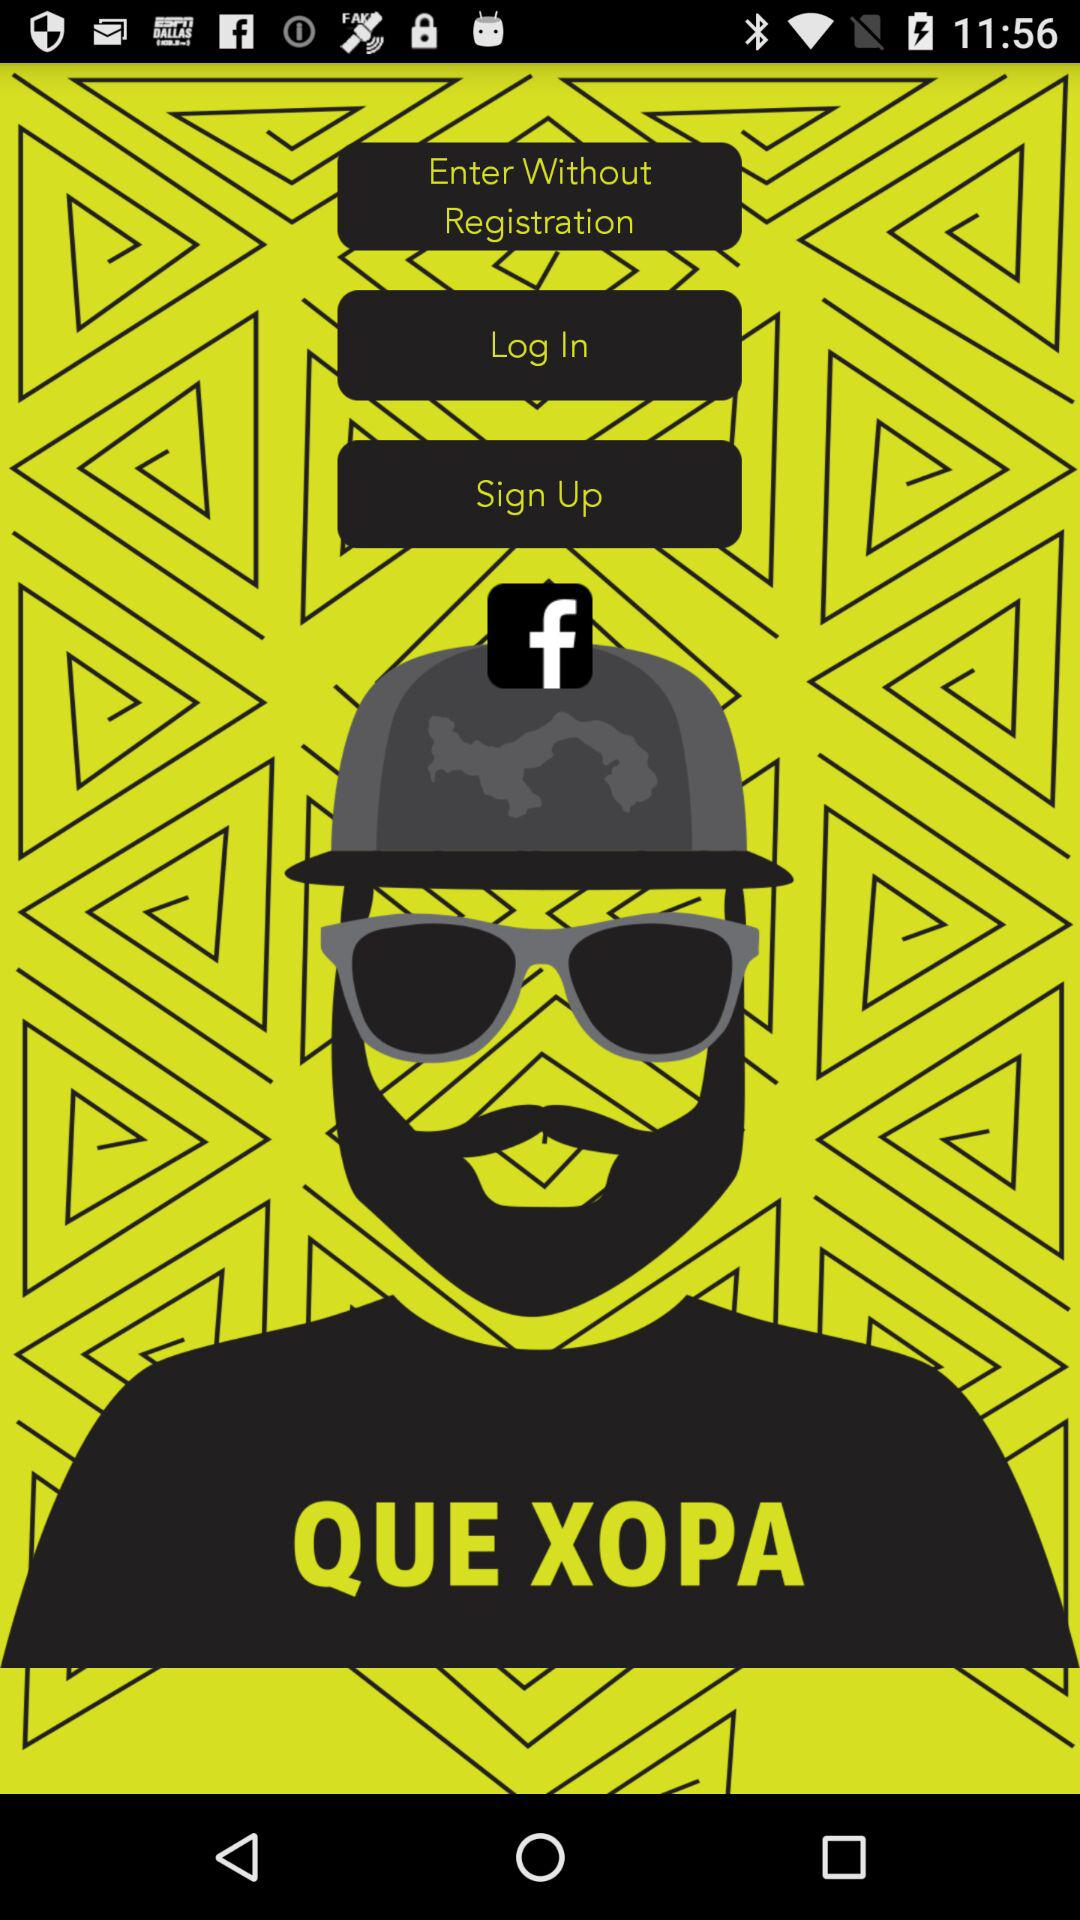Through what application can the user login? The user can login through "Facebook". 